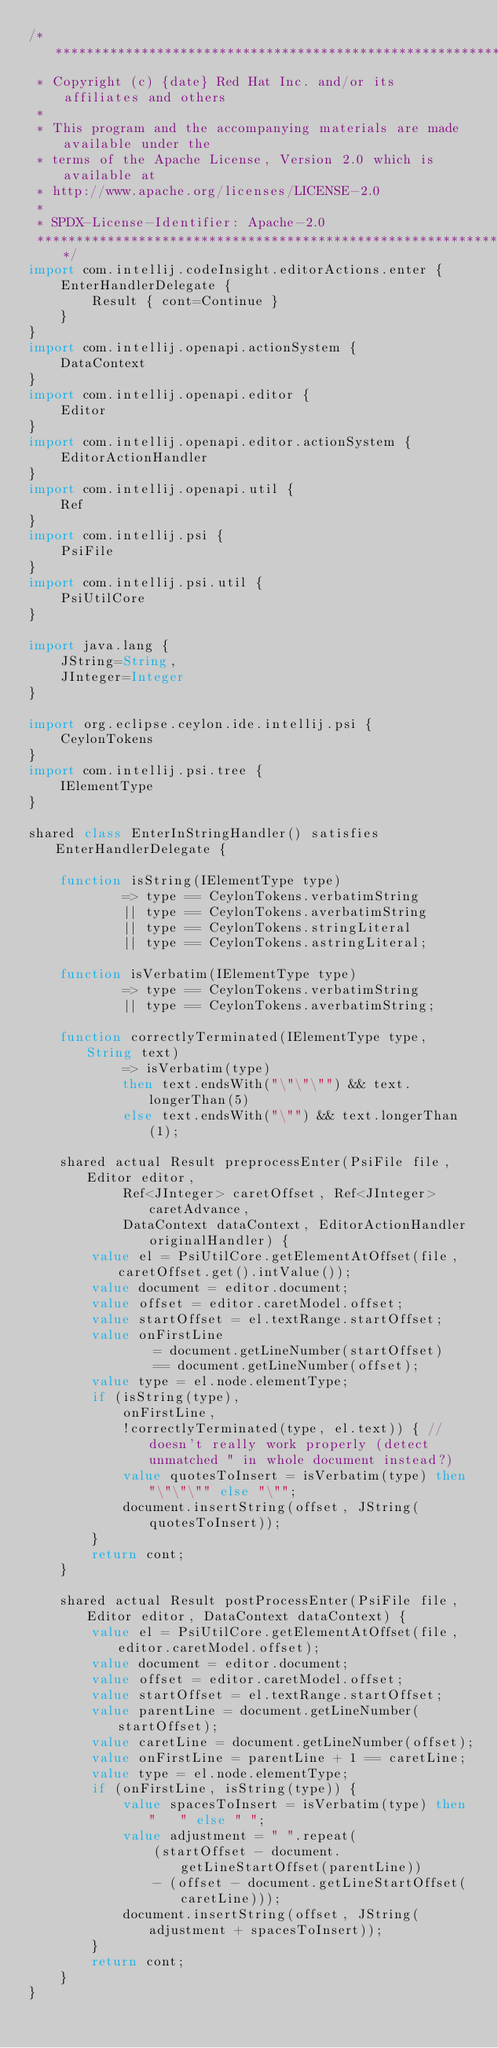<code> <loc_0><loc_0><loc_500><loc_500><_Ceylon_>/********************************************************************************
 * Copyright (c) {date} Red Hat Inc. and/or its affiliates and others
 *
 * This program and the accompanying materials are made available under the 
 * terms of the Apache License, Version 2.0 which is available at
 * http://www.apache.org/licenses/LICENSE-2.0
 *
 * SPDX-License-Identifier: Apache-2.0 
 ********************************************************************************/
import com.intellij.codeInsight.editorActions.enter {
    EnterHandlerDelegate {
        Result { cont=Continue }
    }
}
import com.intellij.openapi.actionSystem {
    DataContext
}
import com.intellij.openapi.editor {
    Editor
}
import com.intellij.openapi.editor.actionSystem {
    EditorActionHandler
}
import com.intellij.openapi.util {
    Ref
}
import com.intellij.psi {
    PsiFile
}
import com.intellij.psi.util {
    PsiUtilCore
}

import java.lang {
    JString=String,
    JInteger=Integer
}

import org.eclipse.ceylon.ide.intellij.psi {
    CeylonTokens
}
import com.intellij.psi.tree {
    IElementType
}

shared class EnterInStringHandler() satisfies EnterHandlerDelegate {

    function isString(IElementType type)
            => type == CeylonTokens.verbatimString
            || type == CeylonTokens.averbatimString
            || type == CeylonTokens.stringLiteral
            || type == CeylonTokens.astringLiteral;

    function isVerbatim(IElementType type)
            => type == CeylonTokens.verbatimString
            || type == CeylonTokens.averbatimString;

    function correctlyTerminated(IElementType type, String text)
            => isVerbatim(type)
            then text.endsWith("\"\"\"") && text.longerThan(5)
            else text.endsWith("\"") && text.longerThan(1);

    shared actual Result preprocessEnter(PsiFile file, Editor editor,
            Ref<JInteger> caretOffset, Ref<JInteger> caretAdvance,
            DataContext dataContext, EditorActionHandler originalHandler) {
        value el = PsiUtilCore.getElementAtOffset(file, caretOffset.get().intValue());
        value document = editor.document;
        value offset = editor.caretModel.offset;
        value startOffset = el.textRange.startOffset;
        value onFirstLine
                = document.getLineNumber(startOffset)
                == document.getLineNumber(offset);
        value type = el.node.elementType;
        if (isString(type),
            onFirstLine,
            !correctlyTerminated(type, el.text)) { //doesn't really work properly (detect unmatched " in whole document instead?)
            value quotesToInsert = isVerbatim(type) then "\"\"\"" else "\"";
            document.insertString(offset, JString(quotesToInsert));
        }
        return cont;
    }

    shared actual Result postProcessEnter(PsiFile file, Editor editor, DataContext dataContext) {
        value el = PsiUtilCore.getElementAtOffset(file, editor.caretModel.offset);
        value document = editor.document;
        value offset = editor.caretModel.offset;
        value startOffset = el.textRange.startOffset;
        value parentLine = document.getLineNumber(startOffset);
        value caretLine = document.getLineNumber(offset);
        value onFirstLine = parentLine + 1 == caretLine;
        value type = el.node.elementType;
        if (onFirstLine, isString(type)) {
            value spacesToInsert = isVerbatim(type) then "   " else " ";
            value adjustment = " ".repeat(
                (startOffset - document.getLineStartOffset(parentLine))
                - (offset - document.getLineStartOffset(caretLine)));
            document.insertString(offset, JString(adjustment + spacesToInsert));
        }
        return cont;
    }
}
</code> 